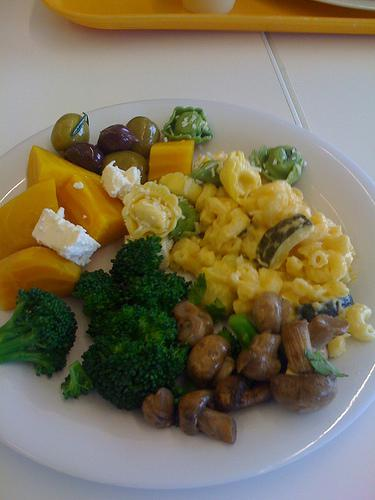Question: what color is the tray?
Choices:
A. Yellow.
B. Red.
C. White.
D. Blue.
Answer with the letter. Answer: A Question: what is to the right of broccoli?
Choices:
A. Mushrooms.
B. Meat.
C. Wine.
D. Plates.
Answer with the letter. Answer: A Question: how many white plates are there?
Choices:
A. Two.
B. Three.
C. Four.
D. One.
Answer with the letter. Answer: D Question: where was the photo taken?
Choices:
A. In a dining area.
B. In a kitchen.
C. In a yard.
D. In a bedroom.
Answer with the letter. Answer: A 